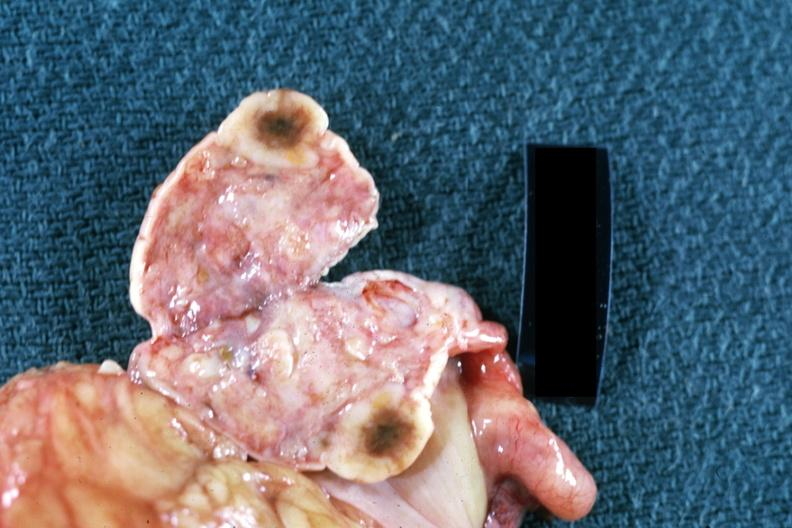does nodular tumor show cut surface of ovary close up breast primary?
Answer the question using a single word or phrase. No 